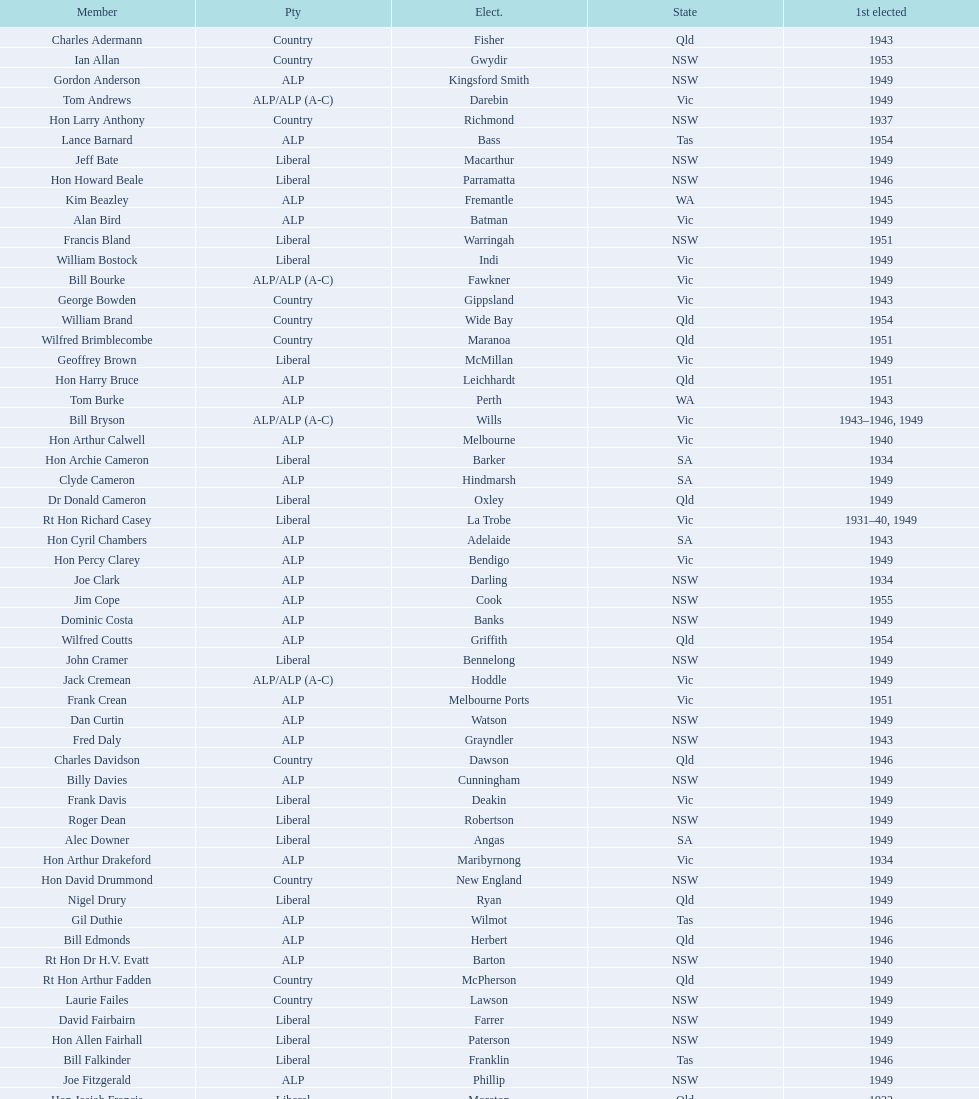Previous to tom andrews who was elected? Gordon Anderson. 